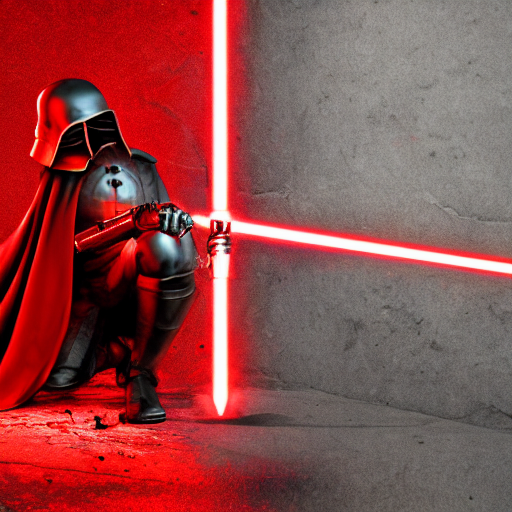What implications does the red color scheme have on the mood of the image? The red color scheme enhances the image's intensity, conveying a sense of danger or urgency. It can evoke strong emotions and suggest that the character is formidable or engaged in conflict. 